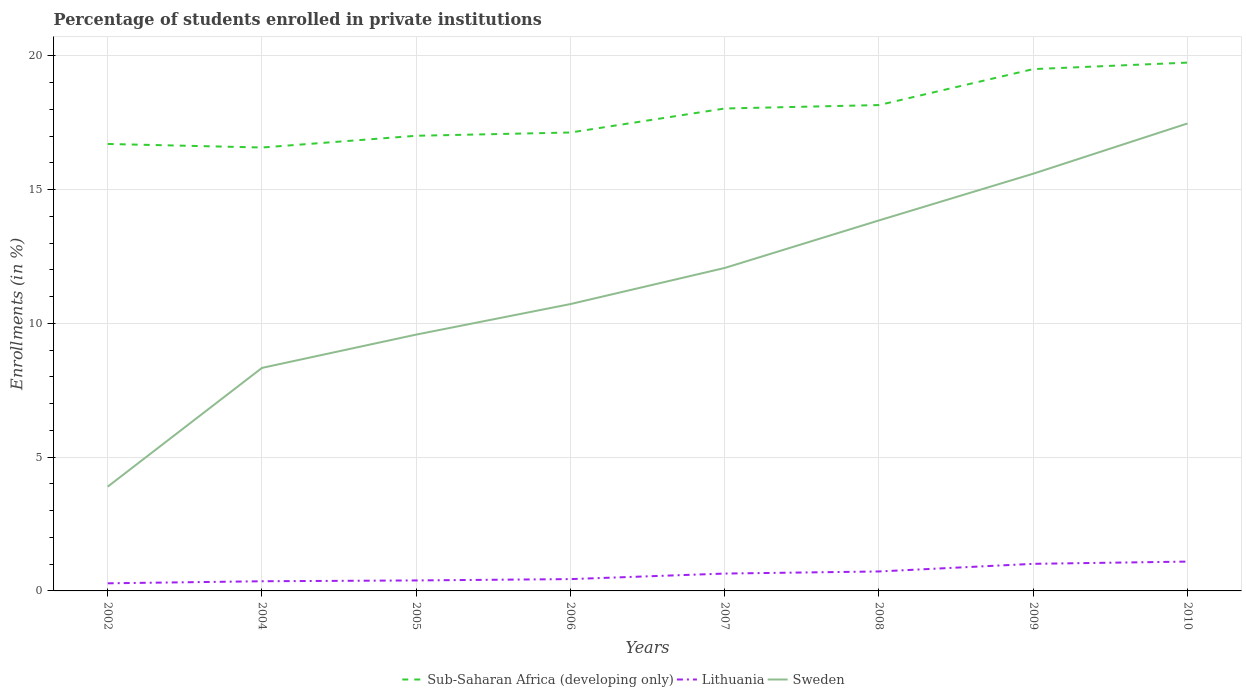How many different coloured lines are there?
Provide a succinct answer. 3. Does the line corresponding to Sub-Saharan Africa (developing only) intersect with the line corresponding to Sweden?
Make the answer very short. No. Across all years, what is the maximum percentage of trained teachers in Lithuania?
Ensure brevity in your answer.  0.28. What is the total percentage of trained teachers in Sweden in the graph?
Your response must be concise. -5.68. What is the difference between the highest and the second highest percentage of trained teachers in Sweden?
Your response must be concise. 13.57. What is the difference between the highest and the lowest percentage of trained teachers in Lithuania?
Your answer should be very brief. 4. Is the percentage of trained teachers in Lithuania strictly greater than the percentage of trained teachers in Sub-Saharan Africa (developing only) over the years?
Offer a very short reply. Yes. How many lines are there?
Make the answer very short. 3. What is the difference between two consecutive major ticks on the Y-axis?
Your response must be concise. 5. Are the values on the major ticks of Y-axis written in scientific E-notation?
Your response must be concise. No. Does the graph contain any zero values?
Offer a very short reply. No. Does the graph contain grids?
Your answer should be compact. Yes. Where does the legend appear in the graph?
Provide a succinct answer. Bottom center. How are the legend labels stacked?
Your answer should be very brief. Horizontal. What is the title of the graph?
Ensure brevity in your answer.  Percentage of students enrolled in private institutions. What is the label or title of the X-axis?
Offer a terse response. Years. What is the label or title of the Y-axis?
Provide a short and direct response. Enrollments (in %). What is the Enrollments (in %) in Sub-Saharan Africa (developing only) in 2002?
Offer a terse response. 16.7. What is the Enrollments (in %) of Lithuania in 2002?
Offer a very short reply. 0.28. What is the Enrollments (in %) in Sweden in 2002?
Your response must be concise. 3.9. What is the Enrollments (in %) of Sub-Saharan Africa (developing only) in 2004?
Provide a succinct answer. 16.57. What is the Enrollments (in %) in Lithuania in 2004?
Provide a short and direct response. 0.36. What is the Enrollments (in %) in Sweden in 2004?
Provide a succinct answer. 8.33. What is the Enrollments (in %) of Sub-Saharan Africa (developing only) in 2005?
Offer a terse response. 17.01. What is the Enrollments (in %) of Lithuania in 2005?
Keep it short and to the point. 0.39. What is the Enrollments (in %) of Sweden in 2005?
Offer a terse response. 9.58. What is the Enrollments (in %) in Sub-Saharan Africa (developing only) in 2006?
Offer a very short reply. 17.13. What is the Enrollments (in %) of Lithuania in 2006?
Your answer should be compact. 0.44. What is the Enrollments (in %) of Sweden in 2006?
Give a very brief answer. 10.72. What is the Enrollments (in %) in Sub-Saharan Africa (developing only) in 2007?
Provide a succinct answer. 18.03. What is the Enrollments (in %) in Lithuania in 2007?
Make the answer very short. 0.65. What is the Enrollments (in %) of Sweden in 2007?
Make the answer very short. 12.07. What is the Enrollments (in %) of Sub-Saharan Africa (developing only) in 2008?
Offer a very short reply. 18.16. What is the Enrollments (in %) of Lithuania in 2008?
Your answer should be compact. 0.73. What is the Enrollments (in %) in Sweden in 2008?
Your answer should be very brief. 13.85. What is the Enrollments (in %) of Sub-Saharan Africa (developing only) in 2009?
Your response must be concise. 19.5. What is the Enrollments (in %) of Lithuania in 2009?
Your response must be concise. 1.01. What is the Enrollments (in %) in Sweden in 2009?
Your answer should be very brief. 15.59. What is the Enrollments (in %) of Sub-Saharan Africa (developing only) in 2010?
Your response must be concise. 19.74. What is the Enrollments (in %) of Lithuania in 2010?
Keep it short and to the point. 1.1. What is the Enrollments (in %) in Sweden in 2010?
Provide a succinct answer. 17.47. Across all years, what is the maximum Enrollments (in %) of Sub-Saharan Africa (developing only)?
Your answer should be very brief. 19.74. Across all years, what is the maximum Enrollments (in %) in Lithuania?
Provide a succinct answer. 1.1. Across all years, what is the maximum Enrollments (in %) of Sweden?
Give a very brief answer. 17.47. Across all years, what is the minimum Enrollments (in %) in Sub-Saharan Africa (developing only)?
Give a very brief answer. 16.57. Across all years, what is the minimum Enrollments (in %) of Lithuania?
Your answer should be compact. 0.28. Across all years, what is the minimum Enrollments (in %) of Sweden?
Your answer should be compact. 3.9. What is the total Enrollments (in %) of Sub-Saharan Africa (developing only) in the graph?
Provide a succinct answer. 142.85. What is the total Enrollments (in %) in Lithuania in the graph?
Keep it short and to the point. 4.96. What is the total Enrollments (in %) of Sweden in the graph?
Provide a succinct answer. 91.51. What is the difference between the Enrollments (in %) in Sub-Saharan Africa (developing only) in 2002 and that in 2004?
Your answer should be very brief. 0.13. What is the difference between the Enrollments (in %) of Lithuania in 2002 and that in 2004?
Your answer should be very brief. -0.08. What is the difference between the Enrollments (in %) of Sweden in 2002 and that in 2004?
Offer a terse response. -4.44. What is the difference between the Enrollments (in %) in Sub-Saharan Africa (developing only) in 2002 and that in 2005?
Make the answer very short. -0.31. What is the difference between the Enrollments (in %) of Lithuania in 2002 and that in 2005?
Provide a succinct answer. -0.11. What is the difference between the Enrollments (in %) of Sweden in 2002 and that in 2005?
Keep it short and to the point. -5.68. What is the difference between the Enrollments (in %) of Sub-Saharan Africa (developing only) in 2002 and that in 2006?
Give a very brief answer. -0.43. What is the difference between the Enrollments (in %) of Lithuania in 2002 and that in 2006?
Offer a very short reply. -0.16. What is the difference between the Enrollments (in %) of Sweden in 2002 and that in 2006?
Keep it short and to the point. -6.82. What is the difference between the Enrollments (in %) in Sub-Saharan Africa (developing only) in 2002 and that in 2007?
Provide a succinct answer. -1.33. What is the difference between the Enrollments (in %) in Lithuania in 2002 and that in 2007?
Offer a terse response. -0.36. What is the difference between the Enrollments (in %) of Sweden in 2002 and that in 2007?
Your answer should be compact. -8.17. What is the difference between the Enrollments (in %) in Sub-Saharan Africa (developing only) in 2002 and that in 2008?
Offer a terse response. -1.45. What is the difference between the Enrollments (in %) in Lithuania in 2002 and that in 2008?
Make the answer very short. -0.44. What is the difference between the Enrollments (in %) of Sweden in 2002 and that in 2008?
Give a very brief answer. -9.95. What is the difference between the Enrollments (in %) of Sub-Saharan Africa (developing only) in 2002 and that in 2009?
Your response must be concise. -2.8. What is the difference between the Enrollments (in %) in Lithuania in 2002 and that in 2009?
Offer a very short reply. -0.73. What is the difference between the Enrollments (in %) in Sweden in 2002 and that in 2009?
Your answer should be very brief. -11.7. What is the difference between the Enrollments (in %) in Sub-Saharan Africa (developing only) in 2002 and that in 2010?
Make the answer very short. -3.04. What is the difference between the Enrollments (in %) in Lithuania in 2002 and that in 2010?
Offer a terse response. -0.81. What is the difference between the Enrollments (in %) of Sweden in 2002 and that in 2010?
Give a very brief answer. -13.57. What is the difference between the Enrollments (in %) in Sub-Saharan Africa (developing only) in 2004 and that in 2005?
Ensure brevity in your answer.  -0.44. What is the difference between the Enrollments (in %) of Lithuania in 2004 and that in 2005?
Your answer should be very brief. -0.03. What is the difference between the Enrollments (in %) in Sweden in 2004 and that in 2005?
Your answer should be compact. -1.24. What is the difference between the Enrollments (in %) in Sub-Saharan Africa (developing only) in 2004 and that in 2006?
Ensure brevity in your answer.  -0.56. What is the difference between the Enrollments (in %) in Lithuania in 2004 and that in 2006?
Your answer should be very brief. -0.08. What is the difference between the Enrollments (in %) in Sweden in 2004 and that in 2006?
Make the answer very short. -2.39. What is the difference between the Enrollments (in %) in Sub-Saharan Africa (developing only) in 2004 and that in 2007?
Your answer should be very brief. -1.46. What is the difference between the Enrollments (in %) in Lithuania in 2004 and that in 2007?
Provide a succinct answer. -0.29. What is the difference between the Enrollments (in %) in Sweden in 2004 and that in 2007?
Provide a succinct answer. -3.73. What is the difference between the Enrollments (in %) of Sub-Saharan Africa (developing only) in 2004 and that in 2008?
Your answer should be compact. -1.59. What is the difference between the Enrollments (in %) in Lithuania in 2004 and that in 2008?
Your answer should be very brief. -0.37. What is the difference between the Enrollments (in %) in Sweden in 2004 and that in 2008?
Provide a succinct answer. -5.51. What is the difference between the Enrollments (in %) in Sub-Saharan Africa (developing only) in 2004 and that in 2009?
Make the answer very short. -2.93. What is the difference between the Enrollments (in %) in Lithuania in 2004 and that in 2009?
Provide a short and direct response. -0.65. What is the difference between the Enrollments (in %) in Sweden in 2004 and that in 2009?
Your response must be concise. -7.26. What is the difference between the Enrollments (in %) in Sub-Saharan Africa (developing only) in 2004 and that in 2010?
Offer a very short reply. -3.17. What is the difference between the Enrollments (in %) in Lithuania in 2004 and that in 2010?
Make the answer very short. -0.73. What is the difference between the Enrollments (in %) in Sweden in 2004 and that in 2010?
Your answer should be very brief. -9.14. What is the difference between the Enrollments (in %) of Sub-Saharan Africa (developing only) in 2005 and that in 2006?
Provide a short and direct response. -0.12. What is the difference between the Enrollments (in %) in Lithuania in 2005 and that in 2006?
Ensure brevity in your answer.  -0.05. What is the difference between the Enrollments (in %) in Sweden in 2005 and that in 2006?
Offer a terse response. -1.14. What is the difference between the Enrollments (in %) of Sub-Saharan Africa (developing only) in 2005 and that in 2007?
Your answer should be compact. -1.02. What is the difference between the Enrollments (in %) of Lithuania in 2005 and that in 2007?
Give a very brief answer. -0.26. What is the difference between the Enrollments (in %) in Sweden in 2005 and that in 2007?
Give a very brief answer. -2.49. What is the difference between the Enrollments (in %) in Sub-Saharan Africa (developing only) in 2005 and that in 2008?
Make the answer very short. -1.15. What is the difference between the Enrollments (in %) in Lithuania in 2005 and that in 2008?
Provide a succinct answer. -0.34. What is the difference between the Enrollments (in %) of Sweden in 2005 and that in 2008?
Keep it short and to the point. -4.27. What is the difference between the Enrollments (in %) of Sub-Saharan Africa (developing only) in 2005 and that in 2009?
Your response must be concise. -2.49. What is the difference between the Enrollments (in %) in Lithuania in 2005 and that in 2009?
Your response must be concise. -0.62. What is the difference between the Enrollments (in %) in Sweden in 2005 and that in 2009?
Your answer should be very brief. -6.01. What is the difference between the Enrollments (in %) in Sub-Saharan Africa (developing only) in 2005 and that in 2010?
Ensure brevity in your answer.  -2.73. What is the difference between the Enrollments (in %) of Lithuania in 2005 and that in 2010?
Give a very brief answer. -0.7. What is the difference between the Enrollments (in %) in Sweden in 2005 and that in 2010?
Ensure brevity in your answer.  -7.89. What is the difference between the Enrollments (in %) in Sub-Saharan Africa (developing only) in 2006 and that in 2007?
Provide a short and direct response. -0.9. What is the difference between the Enrollments (in %) of Lithuania in 2006 and that in 2007?
Give a very brief answer. -0.21. What is the difference between the Enrollments (in %) in Sweden in 2006 and that in 2007?
Your answer should be very brief. -1.35. What is the difference between the Enrollments (in %) of Sub-Saharan Africa (developing only) in 2006 and that in 2008?
Offer a terse response. -1.03. What is the difference between the Enrollments (in %) in Lithuania in 2006 and that in 2008?
Provide a short and direct response. -0.29. What is the difference between the Enrollments (in %) of Sweden in 2006 and that in 2008?
Ensure brevity in your answer.  -3.13. What is the difference between the Enrollments (in %) of Sub-Saharan Africa (developing only) in 2006 and that in 2009?
Your answer should be very brief. -2.37. What is the difference between the Enrollments (in %) in Lithuania in 2006 and that in 2009?
Keep it short and to the point. -0.57. What is the difference between the Enrollments (in %) of Sweden in 2006 and that in 2009?
Provide a short and direct response. -4.87. What is the difference between the Enrollments (in %) of Sub-Saharan Africa (developing only) in 2006 and that in 2010?
Provide a short and direct response. -2.61. What is the difference between the Enrollments (in %) in Lithuania in 2006 and that in 2010?
Your response must be concise. -0.65. What is the difference between the Enrollments (in %) of Sweden in 2006 and that in 2010?
Provide a short and direct response. -6.75. What is the difference between the Enrollments (in %) of Sub-Saharan Africa (developing only) in 2007 and that in 2008?
Provide a succinct answer. -0.13. What is the difference between the Enrollments (in %) of Lithuania in 2007 and that in 2008?
Your answer should be very brief. -0.08. What is the difference between the Enrollments (in %) in Sweden in 2007 and that in 2008?
Make the answer very short. -1.78. What is the difference between the Enrollments (in %) of Sub-Saharan Africa (developing only) in 2007 and that in 2009?
Provide a short and direct response. -1.47. What is the difference between the Enrollments (in %) in Lithuania in 2007 and that in 2009?
Your answer should be very brief. -0.36. What is the difference between the Enrollments (in %) of Sweden in 2007 and that in 2009?
Your response must be concise. -3.52. What is the difference between the Enrollments (in %) of Sub-Saharan Africa (developing only) in 2007 and that in 2010?
Provide a succinct answer. -1.72. What is the difference between the Enrollments (in %) of Lithuania in 2007 and that in 2010?
Make the answer very short. -0.45. What is the difference between the Enrollments (in %) of Sweden in 2007 and that in 2010?
Ensure brevity in your answer.  -5.4. What is the difference between the Enrollments (in %) in Sub-Saharan Africa (developing only) in 2008 and that in 2009?
Keep it short and to the point. -1.34. What is the difference between the Enrollments (in %) in Lithuania in 2008 and that in 2009?
Offer a terse response. -0.28. What is the difference between the Enrollments (in %) of Sweden in 2008 and that in 2009?
Your answer should be very brief. -1.75. What is the difference between the Enrollments (in %) of Sub-Saharan Africa (developing only) in 2008 and that in 2010?
Give a very brief answer. -1.59. What is the difference between the Enrollments (in %) in Lithuania in 2008 and that in 2010?
Your answer should be very brief. -0.37. What is the difference between the Enrollments (in %) in Sweden in 2008 and that in 2010?
Keep it short and to the point. -3.62. What is the difference between the Enrollments (in %) in Sub-Saharan Africa (developing only) in 2009 and that in 2010?
Your answer should be compact. -0.24. What is the difference between the Enrollments (in %) in Lithuania in 2009 and that in 2010?
Offer a terse response. -0.08. What is the difference between the Enrollments (in %) in Sweden in 2009 and that in 2010?
Offer a terse response. -1.88. What is the difference between the Enrollments (in %) in Sub-Saharan Africa (developing only) in 2002 and the Enrollments (in %) in Lithuania in 2004?
Make the answer very short. 16.34. What is the difference between the Enrollments (in %) of Sub-Saharan Africa (developing only) in 2002 and the Enrollments (in %) of Sweden in 2004?
Offer a terse response. 8.37. What is the difference between the Enrollments (in %) of Lithuania in 2002 and the Enrollments (in %) of Sweden in 2004?
Provide a succinct answer. -8.05. What is the difference between the Enrollments (in %) in Sub-Saharan Africa (developing only) in 2002 and the Enrollments (in %) in Lithuania in 2005?
Provide a short and direct response. 16.31. What is the difference between the Enrollments (in %) of Sub-Saharan Africa (developing only) in 2002 and the Enrollments (in %) of Sweden in 2005?
Provide a short and direct response. 7.12. What is the difference between the Enrollments (in %) in Lithuania in 2002 and the Enrollments (in %) in Sweden in 2005?
Keep it short and to the point. -9.3. What is the difference between the Enrollments (in %) in Sub-Saharan Africa (developing only) in 2002 and the Enrollments (in %) in Lithuania in 2006?
Your answer should be compact. 16.26. What is the difference between the Enrollments (in %) of Sub-Saharan Africa (developing only) in 2002 and the Enrollments (in %) of Sweden in 2006?
Ensure brevity in your answer.  5.98. What is the difference between the Enrollments (in %) in Lithuania in 2002 and the Enrollments (in %) in Sweden in 2006?
Your answer should be very brief. -10.44. What is the difference between the Enrollments (in %) in Sub-Saharan Africa (developing only) in 2002 and the Enrollments (in %) in Lithuania in 2007?
Offer a terse response. 16.05. What is the difference between the Enrollments (in %) in Sub-Saharan Africa (developing only) in 2002 and the Enrollments (in %) in Sweden in 2007?
Offer a terse response. 4.63. What is the difference between the Enrollments (in %) in Lithuania in 2002 and the Enrollments (in %) in Sweden in 2007?
Your answer should be very brief. -11.79. What is the difference between the Enrollments (in %) in Sub-Saharan Africa (developing only) in 2002 and the Enrollments (in %) in Lithuania in 2008?
Your answer should be compact. 15.98. What is the difference between the Enrollments (in %) in Sub-Saharan Africa (developing only) in 2002 and the Enrollments (in %) in Sweden in 2008?
Keep it short and to the point. 2.86. What is the difference between the Enrollments (in %) in Lithuania in 2002 and the Enrollments (in %) in Sweden in 2008?
Give a very brief answer. -13.56. What is the difference between the Enrollments (in %) in Sub-Saharan Africa (developing only) in 2002 and the Enrollments (in %) in Lithuania in 2009?
Offer a very short reply. 15.69. What is the difference between the Enrollments (in %) of Sub-Saharan Africa (developing only) in 2002 and the Enrollments (in %) of Sweden in 2009?
Keep it short and to the point. 1.11. What is the difference between the Enrollments (in %) of Lithuania in 2002 and the Enrollments (in %) of Sweden in 2009?
Offer a very short reply. -15.31. What is the difference between the Enrollments (in %) of Sub-Saharan Africa (developing only) in 2002 and the Enrollments (in %) of Lithuania in 2010?
Make the answer very short. 15.61. What is the difference between the Enrollments (in %) in Sub-Saharan Africa (developing only) in 2002 and the Enrollments (in %) in Sweden in 2010?
Ensure brevity in your answer.  -0.77. What is the difference between the Enrollments (in %) of Lithuania in 2002 and the Enrollments (in %) of Sweden in 2010?
Offer a very short reply. -17.19. What is the difference between the Enrollments (in %) in Sub-Saharan Africa (developing only) in 2004 and the Enrollments (in %) in Lithuania in 2005?
Your response must be concise. 16.18. What is the difference between the Enrollments (in %) of Sub-Saharan Africa (developing only) in 2004 and the Enrollments (in %) of Sweden in 2005?
Give a very brief answer. 6.99. What is the difference between the Enrollments (in %) in Lithuania in 2004 and the Enrollments (in %) in Sweden in 2005?
Make the answer very short. -9.22. What is the difference between the Enrollments (in %) in Sub-Saharan Africa (developing only) in 2004 and the Enrollments (in %) in Lithuania in 2006?
Your answer should be compact. 16.13. What is the difference between the Enrollments (in %) of Sub-Saharan Africa (developing only) in 2004 and the Enrollments (in %) of Sweden in 2006?
Provide a short and direct response. 5.85. What is the difference between the Enrollments (in %) of Lithuania in 2004 and the Enrollments (in %) of Sweden in 2006?
Your answer should be very brief. -10.36. What is the difference between the Enrollments (in %) of Sub-Saharan Africa (developing only) in 2004 and the Enrollments (in %) of Lithuania in 2007?
Make the answer very short. 15.92. What is the difference between the Enrollments (in %) in Sub-Saharan Africa (developing only) in 2004 and the Enrollments (in %) in Sweden in 2007?
Provide a succinct answer. 4.5. What is the difference between the Enrollments (in %) in Lithuania in 2004 and the Enrollments (in %) in Sweden in 2007?
Offer a very short reply. -11.71. What is the difference between the Enrollments (in %) in Sub-Saharan Africa (developing only) in 2004 and the Enrollments (in %) in Lithuania in 2008?
Provide a short and direct response. 15.84. What is the difference between the Enrollments (in %) of Sub-Saharan Africa (developing only) in 2004 and the Enrollments (in %) of Sweden in 2008?
Keep it short and to the point. 2.72. What is the difference between the Enrollments (in %) of Lithuania in 2004 and the Enrollments (in %) of Sweden in 2008?
Your answer should be very brief. -13.49. What is the difference between the Enrollments (in %) in Sub-Saharan Africa (developing only) in 2004 and the Enrollments (in %) in Lithuania in 2009?
Provide a succinct answer. 15.56. What is the difference between the Enrollments (in %) in Sub-Saharan Africa (developing only) in 2004 and the Enrollments (in %) in Sweden in 2009?
Give a very brief answer. 0.98. What is the difference between the Enrollments (in %) of Lithuania in 2004 and the Enrollments (in %) of Sweden in 2009?
Your answer should be compact. -15.23. What is the difference between the Enrollments (in %) in Sub-Saharan Africa (developing only) in 2004 and the Enrollments (in %) in Lithuania in 2010?
Your answer should be compact. 15.48. What is the difference between the Enrollments (in %) in Sub-Saharan Africa (developing only) in 2004 and the Enrollments (in %) in Sweden in 2010?
Your answer should be compact. -0.9. What is the difference between the Enrollments (in %) of Lithuania in 2004 and the Enrollments (in %) of Sweden in 2010?
Your answer should be very brief. -17.11. What is the difference between the Enrollments (in %) of Sub-Saharan Africa (developing only) in 2005 and the Enrollments (in %) of Lithuania in 2006?
Keep it short and to the point. 16.57. What is the difference between the Enrollments (in %) of Sub-Saharan Africa (developing only) in 2005 and the Enrollments (in %) of Sweden in 2006?
Offer a terse response. 6.29. What is the difference between the Enrollments (in %) of Lithuania in 2005 and the Enrollments (in %) of Sweden in 2006?
Offer a very short reply. -10.33. What is the difference between the Enrollments (in %) of Sub-Saharan Africa (developing only) in 2005 and the Enrollments (in %) of Lithuania in 2007?
Ensure brevity in your answer.  16.36. What is the difference between the Enrollments (in %) in Sub-Saharan Africa (developing only) in 2005 and the Enrollments (in %) in Sweden in 2007?
Provide a short and direct response. 4.94. What is the difference between the Enrollments (in %) of Lithuania in 2005 and the Enrollments (in %) of Sweden in 2007?
Make the answer very short. -11.68. What is the difference between the Enrollments (in %) in Sub-Saharan Africa (developing only) in 2005 and the Enrollments (in %) in Lithuania in 2008?
Make the answer very short. 16.28. What is the difference between the Enrollments (in %) of Sub-Saharan Africa (developing only) in 2005 and the Enrollments (in %) of Sweden in 2008?
Your response must be concise. 3.16. What is the difference between the Enrollments (in %) of Lithuania in 2005 and the Enrollments (in %) of Sweden in 2008?
Offer a terse response. -13.45. What is the difference between the Enrollments (in %) of Sub-Saharan Africa (developing only) in 2005 and the Enrollments (in %) of Lithuania in 2009?
Provide a short and direct response. 16. What is the difference between the Enrollments (in %) in Sub-Saharan Africa (developing only) in 2005 and the Enrollments (in %) in Sweden in 2009?
Offer a very short reply. 1.42. What is the difference between the Enrollments (in %) of Lithuania in 2005 and the Enrollments (in %) of Sweden in 2009?
Offer a terse response. -15.2. What is the difference between the Enrollments (in %) of Sub-Saharan Africa (developing only) in 2005 and the Enrollments (in %) of Lithuania in 2010?
Provide a succinct answer. 15.91. What is the difference between the Enrollments (in %) in Sub-Saharan Africa (developing only) in 2005 and the Enrollments (in %) in Sweden in 2010?
Keep it short and to the point. -0.46. What is the difference between the Enrollments (in %) in Lithuania in 2005 and the Enrollments (in %) in Sweden in 2010?
Ensure brevity in your answer.  -17.08. What is the difference between the Enrollments (in %) of Sub-Saharan Africa (developing only) in 2006 and the Enrollments (in %) of Lithuania in 2007?
Make the answer very short. 16.48. What is the difference between the Enrollments (in %) of Sub-Saharan Africa (developing only) in 2006 and the Enrollments (in %) of Sweden in 2007?
Keep it short and to the point. 5.06. What is the difference between the Enrollments (in %) in Lithuania in 2006 and the Enrollments (in %) in Sweden in 2007?
Your answer should be compact. -11.63. What is the difference between the Enrollments (in %) in Sub-Saharan Africa (developing only) in 2006 and the Enrollments (in %) in Lithuania in 2008?
Your response must be concise. 16.4. What is the difference between the Enrollments (in %) of Sub-Saharan Africa (developing only) in 2006 and the Enrollments (in %) of Sweden in 2008?
Provide a short and direct response. 3.29. What is the difference between the Enrollments (in %) in Lithuania in 2006 and the Enrollments (in %) in Sweden in 2008?
Keep it short and to the point. -13.4. What is the difference between the Enrollments (in %) in Sub-Saharan Africa (developing only) in 2006 and the Enrollments (in %) in Lithuania in 2009?
Provide a succinct answer. 16.12. What is the difference between the Enrollments (in %) of Sub-Saharan Africa (developing only) in 2006 and the Enrollments (in %) of Sweden in 2009?
Your answer should be very brief. 1.54. What is the difference between the Enrollments (in %) in Lithuania in 2006 and the Enrollments (in %) in Sweden in 2009?
Offer a very short reply. -15.15. What is the difference between the Enrollments (in %) of Sub-Saharan Africa (developing only) in 2006 and the Enrollments (in %) of Lithuania in 2010?
Provide a succinct answer. 16.04. What is the difference between the Enrollments (in %) of Sub-Saharan Africa (developing only) in 2006 and the Enrollments (in %) of Sweden in 2010?
Offer a terse response. -0.34. What is the difference between the Enrollments (in %) in Lithuania in 2006 and the Enrollments (in %) in Sweden in 2010?
Ensure brevity in your answer.  -17.03. What is the difference between the Enrollments (in %) of Sub-Saharan Africa (developing only) in 2007 and the Enrollments (in %) of Lithuania in 2008?
Your answer should be very brief. 17.3. What is the difference between the Enrollments (in %) in Sub-Saharan Africa (developing only) in 2007 and the Enrollments (in %) in Sweden in 2008?
Offer a terse response. 4.18. What is the difference between the Enrollments (in %) of Lithuania in 2007 and the Enrollments (in %) of Sweden in 2008?
Ensure brevity in your answer.  -13.2. What is the difference between the Enrollments (in %) of Sub-Saharan Africa (developing only) in 2007 and the Enrollments (in %) of Lithuania in 2009?
Offer a very short reply. 17.02. What is the difference between the Enrollments (in %) of Sub-Saharan Africa (developing only) in 2007 and the Enrollments (in %) of Sweden in 2009?
Your answer should be compact. 2.44. What is the difference between the Enrollments (in %) of Lithuania in 2007 and the Enrollments (in %) of Sweden in 2009?
Ensure brevity in your answer.  -14.94. What is the difference between the Enrollments (in %) in Sub-Saharan Africa (developing only) in 2007 and the Enrollments (in %) in Lithuania in 2010?
Offer a very short reply. 16.93. What is the difference between the Enrollments (in %) of Sub-Saharan Africa (developing only) in 2007 and the Enrollments (in %) of Sweden in 2010?
Offer a very short reply. 0.56. What is the difference between the Enrollments (in %) of Lithuania in 2007 and the Enrollments (in %) of Sweden in 2010?
Provide a short and direct response. -16.82. What is the difference between the Enrollments (in %) of Sub-Saharan Africa (developing only) in 2008 and the Enrollments (in %) of Lithuania in 2009?
Offer a very short reply. 17.15. What is the difference between the Enrollments (in %) of Sub-Saharan Africa (developing only) in 2008 and the Enrollments (in %) of Sweden in 2009?
Provide a succinct answer. 2.56. What is the difference between the Enrollments (in %) in Lithuania in 2008 and the Enrollments (in %) in Sweden in 2009?
Provide a succinct answer. -14.87. What is the difference between the Enrollments (in %) of Sub-Saharan Africa (developing only) in 2008 and the Enrollments (in %) of Lithuania in 2010?
Offer a very short reply. 17.06. What is the difference between the Enrollments (in %) of Sub-Saharan Africa (developing only) in 2008 and the Enrollments (in %) of Sweden in 2010?
Keep it short and to the point. 0.69. What is the difference between the Enrollments (in %) in Lithuania in 2008 and the Enrollments (in %) in Sweden in 2010?
Provide a short and direct response. -16.74. What is the difference between the Enrollments (in %) in Sub-Saharan Africa (developing only) in 2009 and the Enrollments (in %) in Lithuania in 2010?
Provide a succinct answer. 18.4. What is the difference between the Enrollments (in %) of Sub-Saharan Africa (developing only) in 2009 and the Enrollments (in %) of Sweden in 2010?
Your response must be concise. 2.03. What is the difference between the Enrollments (in %) of Lithuania in 2009 and the Enrollments (in %) of Sweden in 2010?
Give a very brief answer. -16.46. What is the average Enrollments (in %) of Sub-Saharan Africa (developing only) per year?
Your answer should be compact. 17.86. What is the average Enrollments (in %) of Lithuania per year?
Ensure brevity in your answer.  0.62. What is the average Enrollments (in %) in Sweden per year?
Your answer should be very brief. 11.44. In the year 2002, what is the difference between the Enrollments (in %) of Sub-Saharan Africa (developing only) and Enrollments (in %) of Lithuania?
Keep it short and to the point. 16.42. In the year 2002, what is the difference between the Enrollments (in %) in Sub-Saharan Africa (developing only) and Enrollments (in %) in Sweden?
Give a very brief answer. 12.81. In the year 2002, what is the difference between the Enrollments (in %) in Lithuania and Enrollments (in %) in Sweden?
Your response must be concise. -3.61. In the year 2004, what is the difference between the Enrollments (in %) in Sub-Saharan Africa (developing only) and Enrollments (in %) in Lithuania?
Your response must be concise. 16.21. In the year 2004, what is the difference between the Enrollments (in %) in Sub-Saharan Africa (developing only) and Enrollments (in %) in Sweden?
Your answer should be compact. 8.24. In the year 2004, what is the difference between the Enrollments (in %) in Lithuania and Enrollments (in %) in Sweden?
Give a very brief answer. -7.97. In the year 2005, what is the difference between the Enrollments (in %) of Sub-Saharan Africa (developing only) and Enrollments (in %) of Lithuania?
Offer a very short reply. 16.62. In the year 2005, what is the difference between the Enrollments (in %) in Sub-Saharan Africa (developing only) and Enrollments (in %) in Sweden?
Make the answer very short. 7.43. In the year 2005, what is the difference between the Enrollments (in %) of Lithuania and Enrollments (in %) of Sweden?
Offer a terse response. -9.19. In the year 2006, what is the difference between the Enrollments (in %) in Sub-Saharan Africa (developing only) and Enrollments (in %) in Lithuania?
Give a very brief answer. 16.69. In the year 2006, what is the difference between the Enrollments (in %) of Sub-Saharan Africa (developing only) and Enrollments (in %) of Sweden?
Offer a terse response. 6.41. In the year 2006, what is the difference between the Enrollments (in %) of Lithuania and Enrollments (in %) of Sweden?
Your answer should be very brief. -10.28. In the year 2007, what is the difference between the Enrollments (in %) of Sub-Saharan Africa (developing only) and Enrollments (in %) of Lithuania?
Give a very brief answer. 17.38. In the year 2007, what is the difference between the Enrollments (in %) of Sub-Saharan Africa (developing only) and Enrollments (in %) of Sweden?
Offer a terse response. 5.96. In the year 2007, what is the difference between the Enrollments (in %) of Lithuania and Enrollments (in %) of Sweden?
Make the answer very short. -11.42. In the year 2008, what is the difference between the Enrollments (in %) of Sub-Saharan Africa (developing only) and Enrollments (in %) of Lithuania?
Your response must be concise. 17.43. In the year 2008, what is the difference between the Enrollments (in %) in Sub-Saharan Africa (developing only) and Enrollments (in %) in Sweden?
Give a very brief answer. 4.31. In the year 2008, what is the difference between the Enrollments (in %) in Lithuania and Enrollments (in %) in Sweden?
Provide a succinct answer. -13.12. In the year 2009, what is the difference between the Enrollments (in %) in Sub-Saharan Africa (developing only) and Enrollments (in %) in Lithuania?
Make the answer very short. 18.49. In the year 2009, what is the difference between the Enrollments (in %) in Sub-Saharan Africa (developing only) and Enrollments (in %) in Sweden?
Make the answer very short. 3.91. In the year 2009, what is the difference between the Enrollments (in %) in Lithuania and Enrollments (in %) in Sweden?
Make the answer very short. -14.58. In the year 2010, what is the difference between the Enrollments (in %) of Sub-Saharan Africa (developing only) and Enrollments (in %) of Lithuania?
Your response must be concise. 18.65. In the year 2010, what is the difference between the Enrollments (in %) of Sub-Saharan Africa (developing only) and Enrollments (in %) of Sweden?
Give a very brief answer. 2.27. In the year 2010, what is the difference between the Enrollments (in %) of Lithuania and Enrollments (in %) of Sweden?
Your answer should be compact. -16.37. What is the ratio of the Enrollments (in %) in Sub-Saharan Africa (developing only) in 2002 to that in 2004?
Make the answer very short. 1.01. What is the ratio of the Enrollments (in %) of Lithuania in 2002 to that in 2004?
Offer a terse response. 0.79. What is the ratio of the Enrollments (in %) of Sweden in 2002 to that in 2004?
Ensure brevity in your answer.  0.47. What is the ratio of the Enrollments (in %) of Sub-Saharan Africa (developing only) in 2002 to that in 2005?
Your answer should be compact. 0.98. What is the ratio of the Enrollments (in %) in Lithuania in 2002 to that in 2005?
Give a very brief answer. 0.73. What is the ratio of the Enrollments (in %) in Sweden in 2002 to that in 2005?
Your answer should be very brief. 0.41. What is the ratio of the Enrollments (in %) in Sub-Saharan Africa (developing only) in 2002 to that in 2006?
Offer a terse response. 0.97. What is the ratio of the Enrollments (in %) of Lithuania in 2002 to that in 2006?
Keep it short and to the point. 0.64. What is the ratio of the Enrollments (in %) in Sweden in 2002 to that in 2006?
Your response must be concise. 0.36. What is the ratio of the Enrollments (in %) of Sub-Saharan Africa (developing only) in 2002 to that in 2007?
Give a very brief answer. 0.93. What is the ratio of the Enrollments (in %) in Lithuania in 2002 to that in 2007?
Your response must be concise. 0.44. What is the ratio of the Enrollments (in %) in Sweden in 2002 to that in 2007?
Your answer should be compact. 0.32. What is the ratio of the Enrollments (in %) in Sub-Saharan Africa (developing only) in 2002 to that in 2008?
Make the answer very short. 0.92. What is the ratio of the Enrollments (in %) in Lithuania in 2002 to that in 2008?
Your answer should be compact. 0.39. What is the ratio of the Enrollments (in %) of Sweden in 2002 to that in 2008?
Make the answer very short. 0.28. What is the ratio of the Enrollments (in %) in Sub-Saharan Africa (developing only) in 2002 to that in 2009?
Your response must be concise. 0.86. What is the ratio of the Enrollments (in %) in Lithuania in 2002 to that in 2009?
Your response must be concise. 0.28. What is the ratio of the Enrollments (in %) of Sweden in 2002 to that in 2009?
Offer a terse response. 0.25. What is the ratio of the Enrollments (in %) in Sub-Saharan Africa (developing only) in 2002 to that in 2010?
Your response must be concise. 0.85. What is the ratio of the Enrollments (in %) of Lithuania in 2002 to that in 2010?
Make the answer very short. 0.26. What is the ratio of the Enrollments (in %) of Sweden in 2002 to that in 2010?
Keep it short and to the point. 0.22. What is the ratio of the Enrollments (in %) in Sub-Saharan Africa (developing only) in 2004 to that in 2005?
Offer a very short reply. 0.97. What is the ratio of the Enrollments (in %) of Lithuania in 2004 to that in 2005?
Give a very brief answer. 0.92. What is the ratio of the Enrollments (in %) of Sweden in 2004 to that in 2005?
Provide a succinct answer. 0.87. What is the ratio of the Enrollments (in %) in Sub-Saharan Africa (developing only) in 2004 to that in 2006?
Provide a succinct answer. 0.97. What is the ratio of the Enrollments (in %) in Lithuania in 2004 to that in 2006?
Your response must be concise. 0.82. What is the ratio of the Enrollments (in %) of Sweden in 2004 to that in 2006?
Provide a short and direct response. 0.78. What is the ratio of the Enrollments (in %) in Sub-Saharan Africa (developing only) in 2004 to that in 2007?
Keep it short and to the point. 0.92. What is the ratio of the Enrollments (in %) of Lithuania in 2004 to that in 2007?
Give a very brief answer. 0.56. What is the ratio of the Enrollments (in %) in Sweden in 2004 to that in 2007?
Your answer should be compact. 0.69. What is the ratio of the Enrollments (in %) in Sub-Saharan Africa (developing only) in 2004 to that in 2008?
Make the answer very short. 0.91. What is the ratio of the Enrollments (in %) in Lithuania in 2004 to that in 2008?
Ensure brevity in your answer.  0.5. What is the ratio of the Enrollments (in %) of Sweden in 2004 to that in 2008?
Provide a succinct answer. 0.6. What is the ratio of the Enrollments (in %) in Sub-Saharan Africa (developing only) in 2004 to that in 2009?
Give a very brief answer. 0.85. What is the ratio of the Enrollments (in %) of Lithuania in 2004 to that in 2009?
Ensure brevity in your answer.  0.36. What is the ratio of the Enrollments (in %) in Sweden in 2004 to that in 2009?
Provide a short and direct response. 0.53. What is the ratio of the Enrollments (in %) of Sub-Saharan Africa (developing only) in 2004 to that in 2010?
Ensure brevity in your answer.  0.84. What is the ratio of the Enrollments (in %) of Lithuania in 2004 to that in 2010?
Offer a very short reply. 0.33. What is the ratio of the Enrollments (in %) in Sweden in 2004 to that in 2010?
Offer a terse response. 0.48. What is the ratio of the Enrollments (in %) of Lithuania in 2005 to that in 2006?
Offer a very short reply. 0.89. What is the ratio of the Enrollments (in %) of Sweden in 2005 to that in 2006?
Make the answer very short. 0.89. What is the ratio of the Enrollments (in %) of Sub-Saharan Africa (developing only) in 2005 to that in 2007?
Give a very brief answer. 0.94. What is the ratio of the Enrollments (in %) of Lithuania in 2005 to that in 2007?
Ensure brevity in your answer.  0.6. What is the ratio of the Enrollments (in %) in Sweden in 2005 to that in 2007?
Your answer should be very brief. 0.79. What is the ratio of the Enrollments (in %) in Sub-Saharan Africa (developing only) in 2005 to that in 2008?
Your answer should be compact. 0.94. What is the ratio of the Enrollments (in %) in Lithuania in 2005 to that in 2008?
Provide a short and direct response. 0.54. What is the ratio of the Enrollments (in %) in Sweden in 2005 to that in 2008?
Provide a succinct answer. 0.69. What is the ratio of the Enrollments (in %) of Sub-Saharan Africa (developing only) in 2005 to that in 2009?
Your response must be concise. 0.87. What is the ratio of the Enrollments (in %) in Lithuania in 2005 to that in 2009?
Ensure brevity in your answer.  0.39. What is the ratio of the Enrollments (in %) of Sweden in 2005 to that in 2009?
Provide a succinct answer. 0.61. What is the ratio of the Enrollments (in %) of Sub-Saharan Africa (developing only) in 2005 to that in 2010?
Offer a very short reply. 0.86. What is the ratio of the Enrollments (in %) in Lithuania in 2005 to that in 2010?
Your response must be concise. 0.36. What is the ratio of the Enrollments (in %) in Sweden in 2005 to that in 2010?
Make the answer very short. 0.55. What is the ratio of the Enrollments (in %) of Sub-Saharan Africa (developing only) in 2006 to that in 2007?
Provide a succinct answer. 0.95. What is the ratio of the Enrollments (in %) of Lithuania in 2006 to that in 2007?
Keep it short and to the point. 0.68. What is the ratio of the Enrollments (in %) of Sweden in 2006 to that in 2007?
Offer a very short reply. 0.89. What is the ratio of the Enrollments (in %) in Sub-Saharan Africa (developing only) in 2006 to that in 2008?
Your answer should be very brief. 0.94. What is the ratio of the Enrollments (in %) in Lithuania in 2006 to that in 2008?
Your answer should be very brief. 0.61. What is the ratio of the Enrollments (in %) in Sweden in 2006 to that in 2008?
Offer a terse response. 0.77. What is the ratio of the Enrollments (in %) in Sub-Saharan Africa (developing only) in 2006 to that in 2009?
Offer a very short reply. 0.88. What is the ratio of the Enrollments (in %) of Lithuania in 2006 to that in 2009?
Offer a very short reply. 0.44. What is the ratio of the Enrollments (in %) in Sweden in 2006 to that in 2009?
Make the answer very short. 0.69. What is the ratio of the Enrollments (in %) of Sub-Saharan Africa (developing only) in 2006 to that in 2010?
Keep it short and to the point. 0.87. What is the ratio of the Enrollments (in %) in Lithuania in 2006 to that in 2010?
Provide a succinct answer. 0.4. What is the ratio of the Enrollments (in %) in Sweden in 2006 to that in 2010?
Offer a terse response. 0.61. What is the ratio of the Enrollments (in %) in Lithuania in 2007 to that in 2008?
Make the answer very short. 0.89. What is the ratio of the Enrollments (in %) of Sweden in 2007 to that in 2008?
Provide a succinct answer. 0.87. What is the ratio of the Enrollments (in %) in Sub-Saharan Africa (developing only) in 2007 to that in 2009?
Your response must be concise. 0.92. What is the ratio of the Enrollments (in %) of Lithuania in 2007 to that in 2009?
Give a very brief answer. 0.64. What is the ratio of the Enrollments (in %) in Sweden in 2007 to that in 2009?
Provide a succinct answer. 0.77. What is the ratio of the Enrollments (in %) of Sub-Saharan Africa (developing only) in 2007 to that in 2010?
Your answer should be compact. 0.91. What is the ratio of the Enrollments (in %) in Lithuania in 2007 to that in 2010?
Offer a terse response. 0.59. What is the ratio of the Enrollments (in %) of Sweden in 2007 to that in 2010?
Give a very brief answer. 0.69. What is the ratio of the Enrollments (in %) in Sub-Saharan Africa (developing only) in 2008 to that in 2009?
Ensure brevity in your answer.  0.93. What is the ratio of the Enrollments (in %) of Lithuania in 2008 to that in 2009?
Your answer should be compact. 0.72. What is the ratio of the Enrollments (in %) of Sweden in 2008 to that in 2009?
Ensure brevity in your answer.  0.89. What is the ratio of the Enrollments (in %) in Sub-Saharan Africa (developing only) in 2008 to that in 2010?
Your answer should be compact. 0.92. What is the ratio of the Enrollments (in %) of Lithuania in 2008 to that in 2010?
Offer a very short reply. 0.66. What is the ratio of the Enrollments (in %) of Sweden in 2008 to that in 2010?
Offer a terse response. 0.79. What is the ratio of the Enrollments (in %) of Lithuania in 2009 to that in 2010?
Your response must be concise. 0.92. What is the ratio of the Enrollments (in %) of Sweden in 2009 to that in 2010?
Offer a very short reply. 0.89. What is the difference between the highest and the second highest Enrollments (in %) of Sub-Saharan Africa (developing only)?
Your answer should be compact. 0.24. What is the difference between the highest and the second highest Enrollments (in %) in Lithuania?
Ensure brevity in your answer.  0.08. What is the difference between the highest and the second highest Enrollments (in %) in Sweden?
Your response must be concise. 1.88. What is the difference between the highest and the lowest Enrollments (in %) in Sub-Saharan Africa (developing only)?
Your answer should be very brief. 3.17. What is the difference between the highest and the lowest Enrollments (in %) of Lithuania?
Your answer should be compact. 0.81. What is the difference between the highest and the lowest Enrollments (in %) of Sweden?
Offer a very short reply. 13.57. 